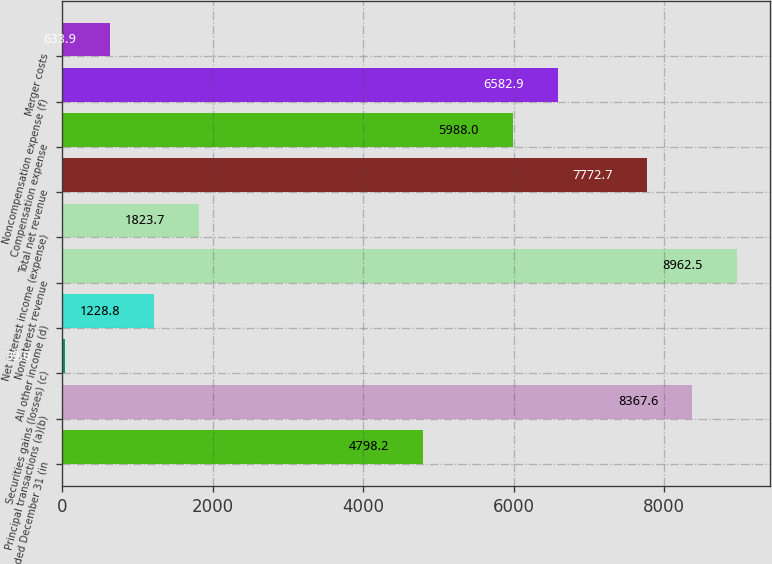Convert chart. <chart><loc_0><loc_0><loc_500><loc_500><bar_chart><fcel>Year ended December 31 (in<fcel>Principal transactions (a)(b)<fcel>Securities gains (losses) (c)<fcel>All other income (d)<fcel>Noninterest revenue<fcel>Net interest income (expense)<fcel>Total net revenue<fcel>Compensation expense<fcel>Noncompensation expense (f)<fcel>Merger costs<nl><fcel>4798.2<fcel>8367.6<fcel>39<fcel>1228.8<fcel>8962.5<fcel>1823.7<fcel>7772.7<fcel>5988<fcel>6582.9<fcel>633.9<nl></chart> 